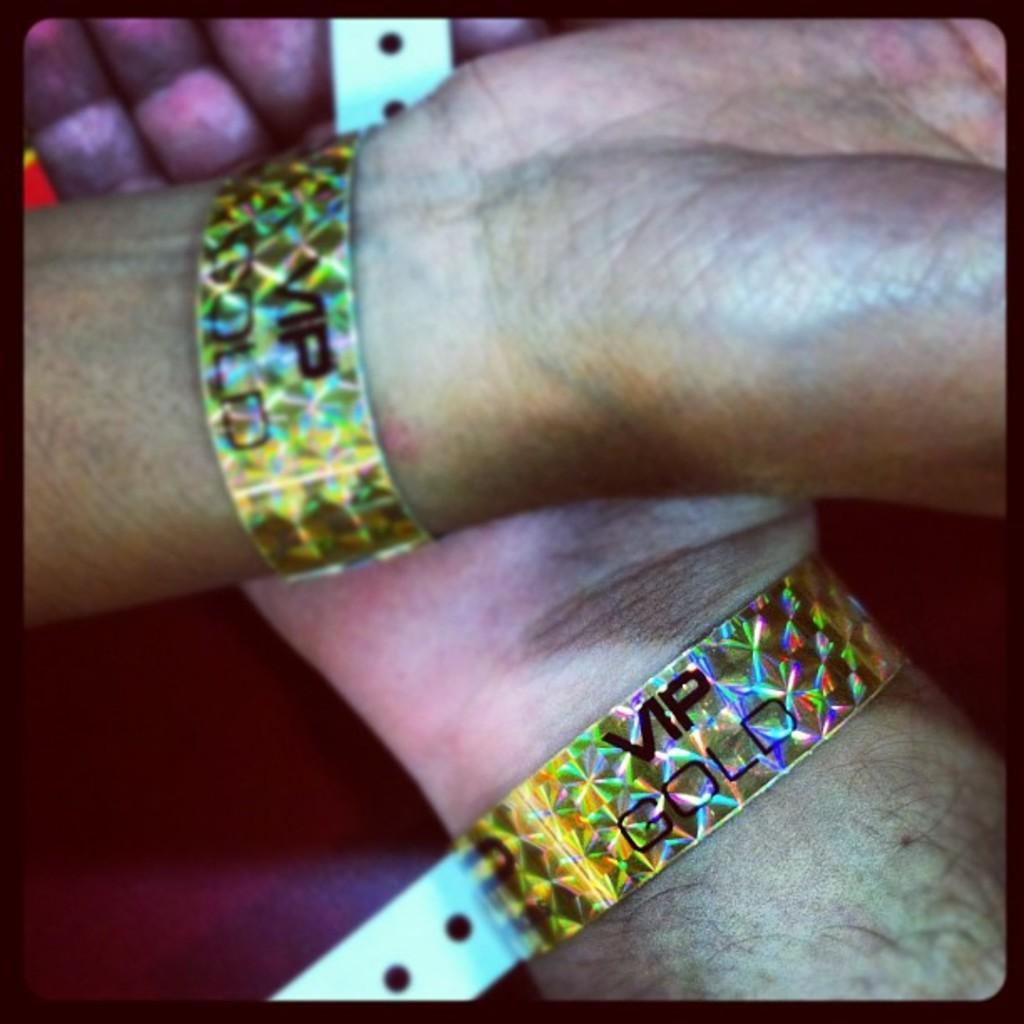How would you summarize this image in a sentence or two? In this picture we can see hands of a person wearing wristbands. We can see it is written as "VIP GOLD" on the bands. 